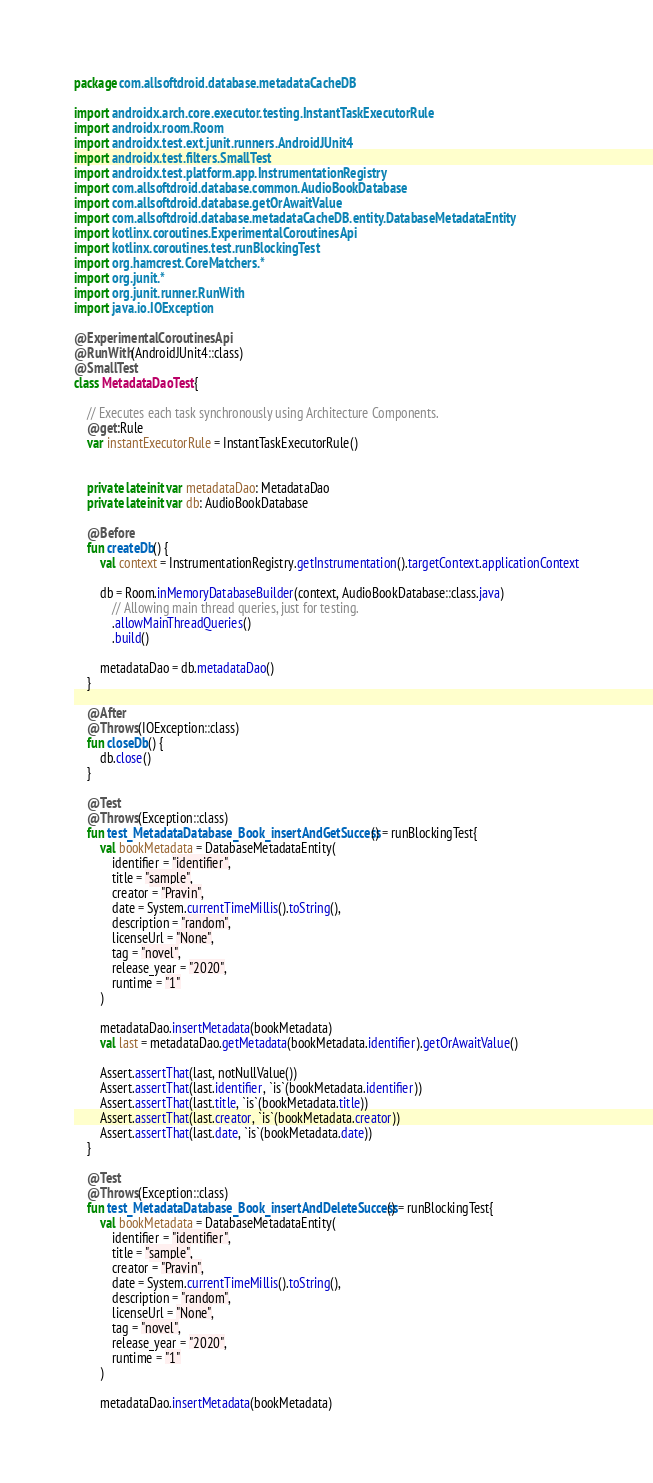Convert code to text. <code><loc_0><loc_0><loc_500><loc_500><_Kotlin_>package com.allsoftdroid.database.metadataCacheDB

import androidx.arch.core.executor.testing.InstantTaskExecutorRule
import androidx.room.Room
import androidx.test.ext.junit.runners.AndroidJUnit4
import androidx.test.filters.SmallTest
import androidx.test.platform.app.InstrumentationRegistry
import com.allsoftdroid.database.common.AudioBookDatabase
import com.allsoftdroid.database.getOrAwaitValue
import com.allsoftdroid.database.metadataCacheDB.entity.DatabaseMetadataEntity
import kotlinx.coroutines.ExperimentalCoroutinesApi
import kotlinx.coroutines.test.runBlockingTest
import org.hamcrest.CoreMatchers.*
import org.junit.*
import org.junit.runner.RunWith
import java.io.IOException

@ExperimentalCoroutinesApi
@RunWith(AndroidJUnit4::class)
@SmallTest
class MetadataDaoTest {

    // Executes each task synchronously using Architecture Components.
    @get:Rule
    var instantExecutorRule = InstantTaskExecutorRule()


    private lateinit var metadataDao: MetadataDao
    private lateinit var db: AudioBookDatabase

    @Before
    fun createDb() {
        val context = InstrumentationRegistry.getInstrumentation().targetContext.applicationContext

        db = Room.inMemoryDatabaseBuilder(context, AudioBookDatabase::class.java)
            // Allowing main thread queries, just for testing.
            .allowMainThreadQueries()
            .build()

        metadataDao = db.metadataDao()
    }

    @After
    @Throws(IOException::class)
    fun closeDb() {
        db.close()
    }

    @Test
    @Throws(Exception::class)
    fun test_MetadataDatabase_Book_insertAndGetSuccess() = runBlockingTest{
        val bookMetadata = DatabaseMetadataEntity(
            identifier = "identifier",
            title = "sample",
            creator = "Pravin",
            date = System.currentTimeMillis().toString(),
            description = "random",
            licenseUrl = "None",
            tag = "novel",
            release_year = "2020",
            runtime = "1"
        )

        metadataDao.insertMetadata(bookMetadata)
        val last = metadataDao.getMetadata(bookMetadata.identifier).getOrAwaitValue()

        Assert.assertThat(last, notNullValue())
        Assert.assertThat(last.identifier, `is`(bookMetadata.identifier))
        Assert.assertThat(last.title, `is`(bookMetadata.title))
        Assert.assertThat(last.creator, `is`(bookMetadata.creator))
        Assert.assertThat(last.date, `is`(bookMetadata.date))
    }

    @Test
    @Throws(Exception::class)
    fun test_MetadataDatabase_Book_insertAndDeleteSuccess() = runBlockingTest{
        val bookMetadata = DatabaseMetadataEntity(
            identifier = "identifier",
            title = "sample",
            creator = "Pravin",
            date = System.currentTimeMillis().toString(),
            description = "random",
            licenseUrl = "None",
            tag = "novel",
            release_year = "2020",
            runtime = "1"
        )

        metadataDao.insertMetadata(bookMetadata)</code> 